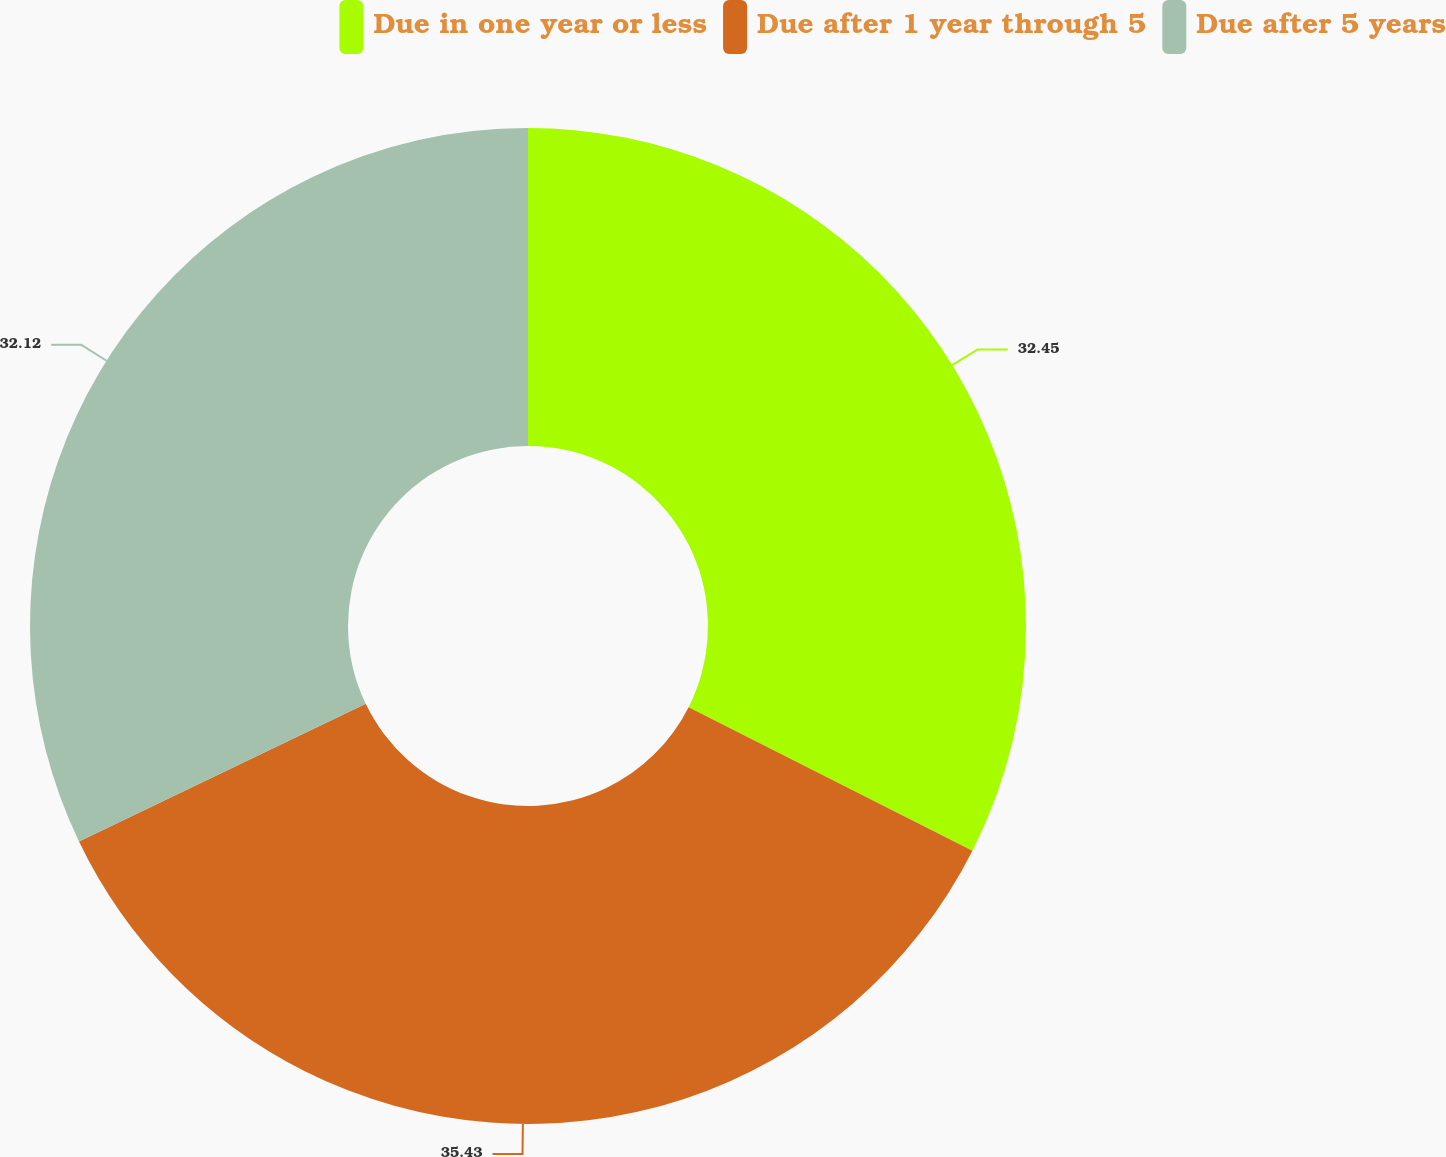Convert chart. <chart><loc_0><loc_0><loc_500><loc_500><pie_chart><fcel>Due in one year or less<fcel>Due after 1 year through 5<fcel>Due after 5 years<nl><fcel>32.45%<fcel>35.43%<fcel>32.12%<nl></chart> 